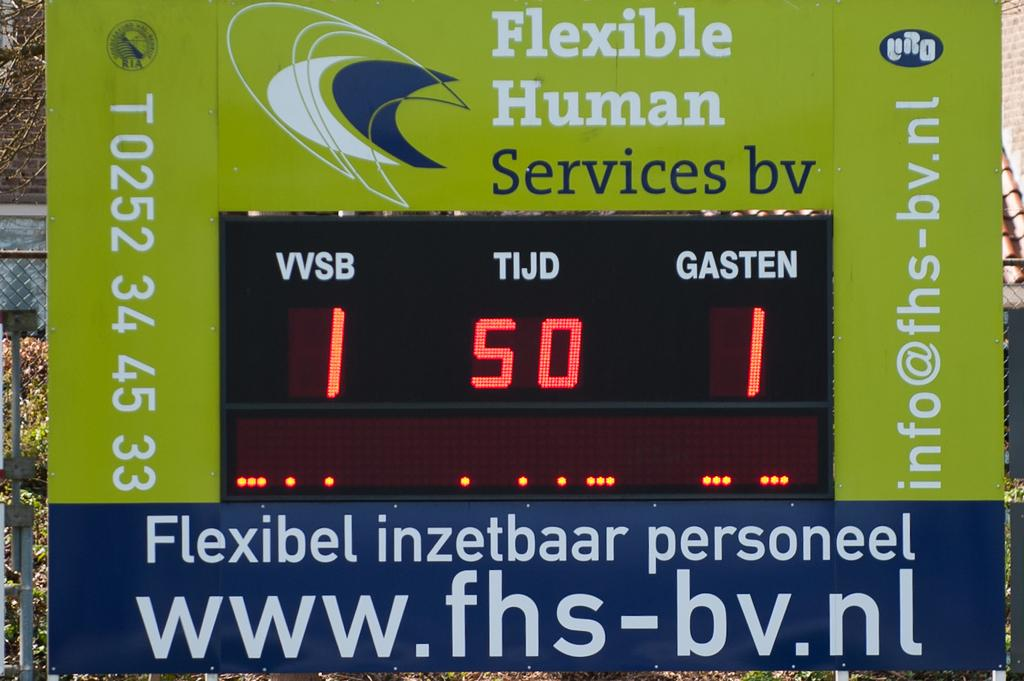<image>
Relay a brief, clear account of the picture shown. A Flexible Human Services sign says that TIJD is 50. 